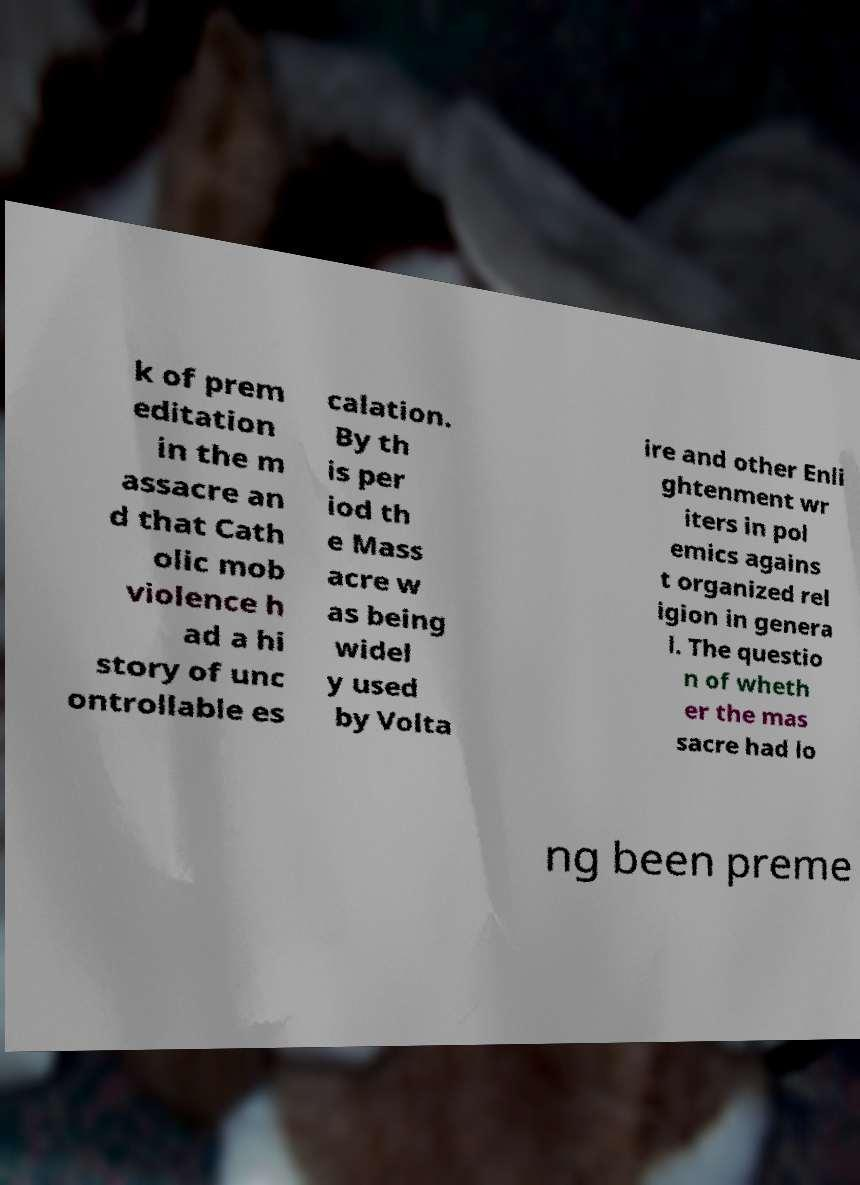Please identify and transcribe the text found in this image. k of prem editation in the m assacre an d that Cath olic mob violence h ad a hi story of unc ontrollable es calation. By th is per iod th e Mass acre w as being widel y used by Volta ire and other Enli ghtenment wr iters in pol emics agains t organized rel igion in genera l. The questio n of wheth er the mas sacre had lo ng been preme 